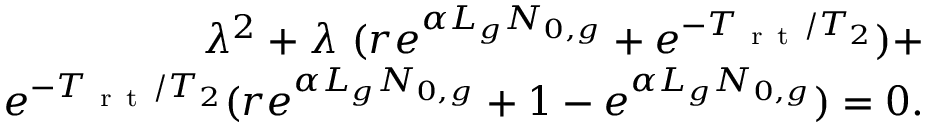<formula> <loc_0><loc_0><loc_500><loc_500>\begin{array} { r } { \lambda ^ { 2 } + \lambda \ ( r e ^ { \alpha L _ { g } N _ { 0 , g } } + e ^ { - T _ { r t } / T _ { 2 } } ) + } \\ { e ^ { - T _ { r t } / T _ { 2 } } ( r e ^ { \alpha L _ { g } N _ { 0 , g } } + 1 - e ^ { \alpha L _ { g } N _ { 0 , g } } ) = 0 . } \end{array}</formula> 